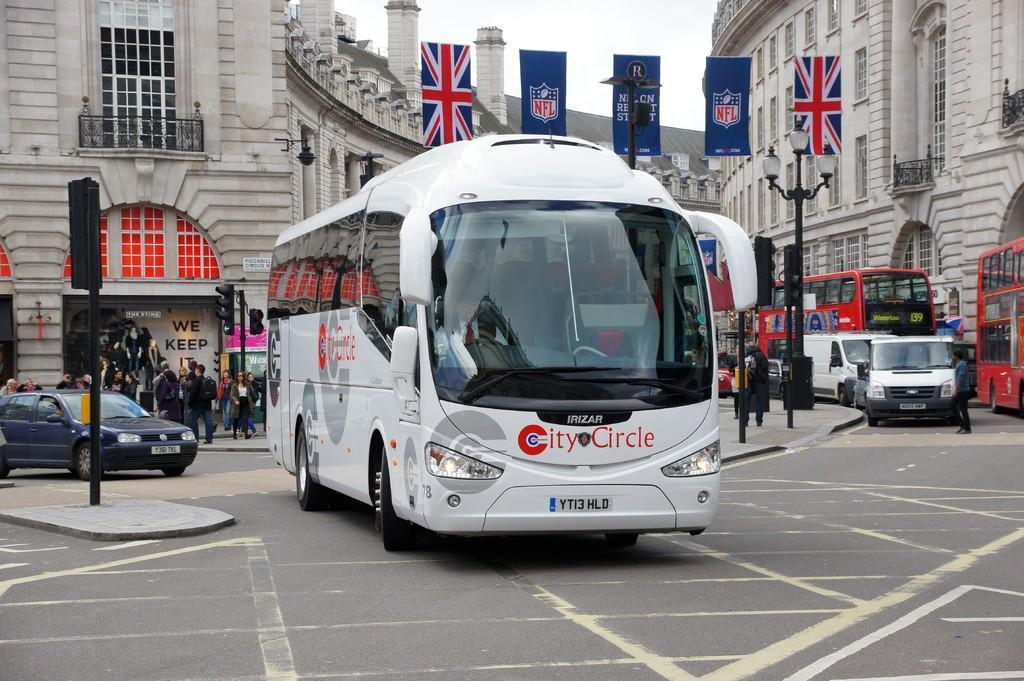Describe this image in one or two sentences. In this image, we can see buildings. There are some vehicles on the road. There are flags and poles in the middle of the image. There is an another pole and some persons on the left side of the image. There is a sky at the top of the image. 